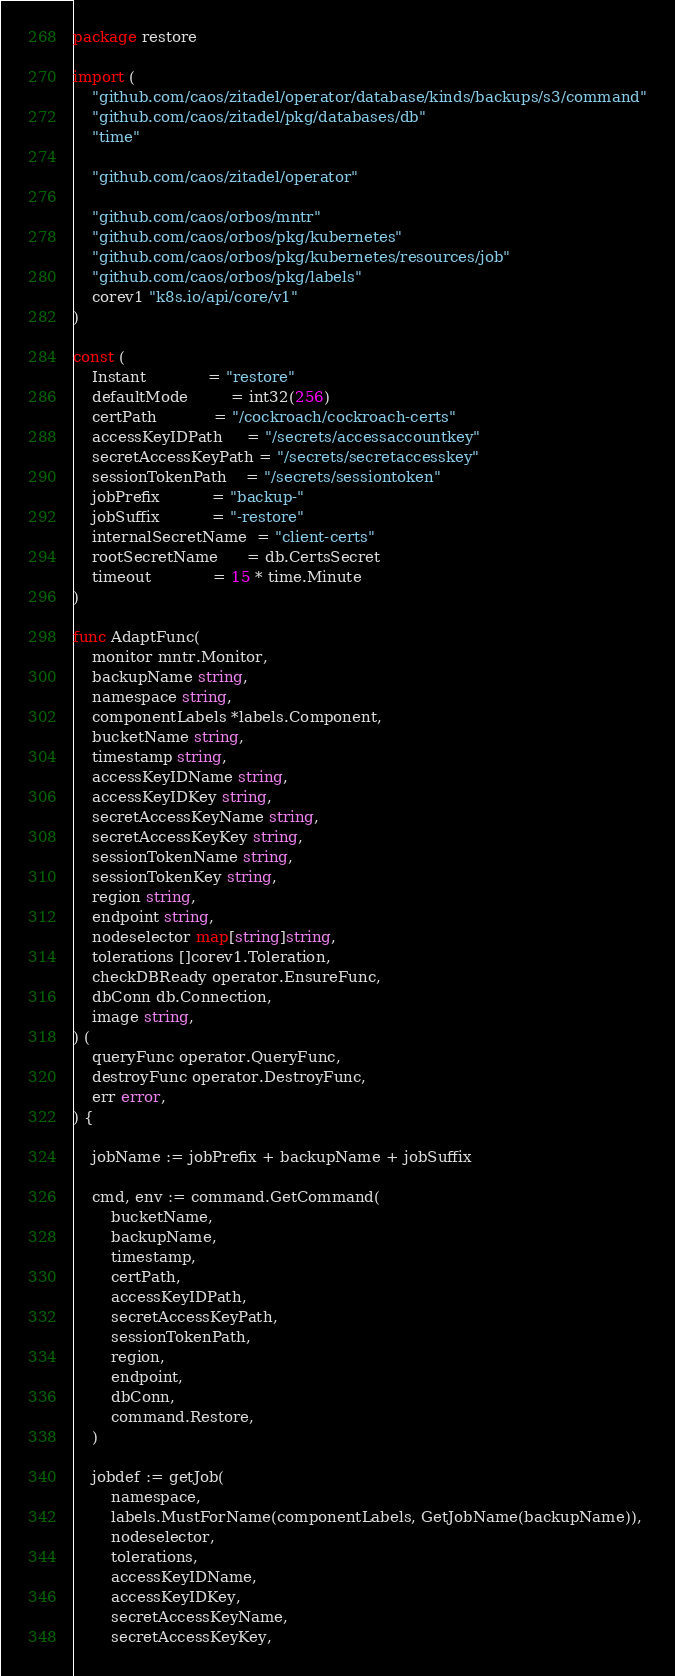Convert code to text. <code><loc_0><loc_0><loc_500><loc_500><_Go_>package restore

import (
	"github.com/caos/zitadel/operator/database/kinds/backups/s3/command"
	"github.com/caos/zitadel/pkg/databases/db"
	"time"

	"github.com/caos/zitadel/operator"

	"github.com/caos/orbos/mntr"
	"github.com/caos/orbos/pkg/kubernetes"
	"github.com/caos/orbos/pkg/kubernetes/resources/job"
	"github.com/caos/orbos/pkg/labels"
	corev1 "k8s.io/api/core/v1"
)

const (
	Instant             = "restore"
	defaultMode         = int32(256)
	certPath            = "/cockroach/cockroach-certs"
	accessKeyIDPath     = "/secrets/accessaccountkey"
	secretAccessKeyPath = "/secrets/secretaccesskey"
	sessionTokenPath    = "/secrets/sessiontoken"
	jobPrefix           = "backup-"
	jobSuffix           = "-restore"
	internalSecretName  = "client-certs"
	rootSecretName      = db.CertsSecret
	timeout             = 15 * time.Minute
)

func AdaptFunc(
	monitor mntr.Monitor,
	backupName string,
	namespace string,
	componentLabels *labels.Component,
	bucketName string,
	timestamp string,
	accessKeyIDName string,
	accessKeyIDKey string,
	secretAccessKeyName string,
	secretAccessKeyKey string,
	sessionTokenName string,
	sessionTokenKey string,
	region string,
	endpoint string,
	nodeselector map[string]string,
	tolerations []corev1.Toleration,
	checkDBReady operator.EnsureFunc,
	dbConn db.Connection,
	image string,
) (
	queryFunc operator.QueryFunc,
	destroyFunc operator.DestroyFunc,
	err error,
) {

	jobName := jobPrefix + backupName + jobSuffix

	cmd, env := command.GetCommand(
		bucketName,
		backupName,
		timestamp,
		certPath,
		accessKeyIDPath,
		secretAccessKeyPath,
		sessionTokenPath,
		region,
		endpoint,
		dbConn,
		command.Restore,
	)

	jobdef := getJob(
		namespace,
		labels.MustForName(componentLabels, GetJobName(backupName)),
		nodeselector,
		tolerations,
		accessKeyIDName,
		accessKeyIDKey,
		secretAccessKeyName,
		secretAccessKeyKey,</code> 